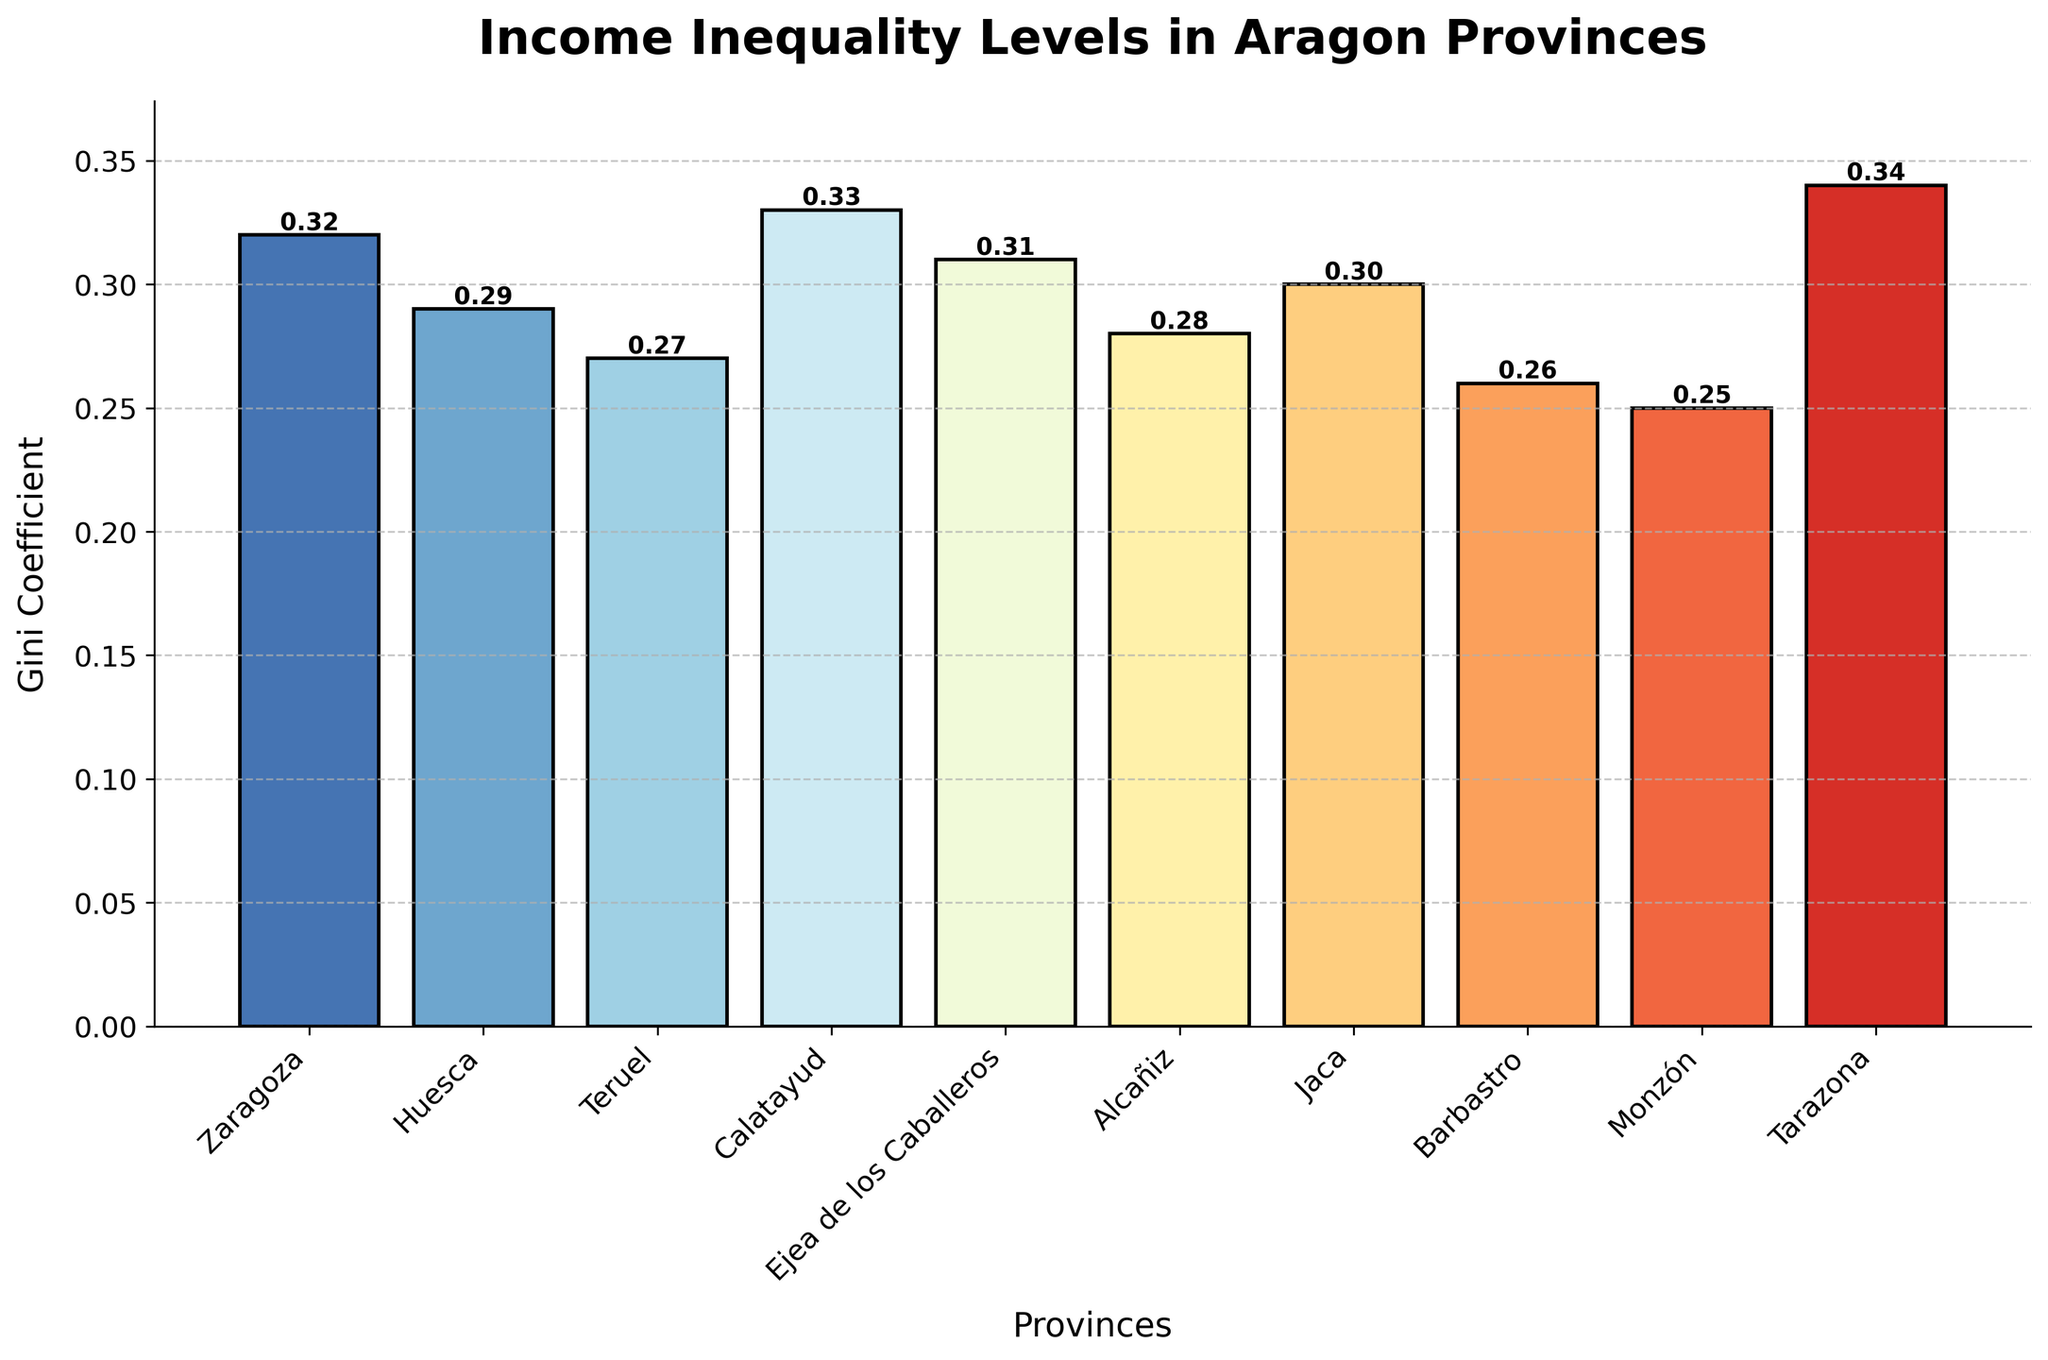Which province has the highest Gini Coefficient? The highest bar represents the highest Gini Coefficient. This is the bar for Tarazona with a Gini Coefficient of 0.34.
Answer: Tarazona Which province has the lowest Gini Coefficient? The lowest bar represents the lowest Gini Coefficient. This is the bar for Monzón with a Gini Coefficient of 0.25.
Answer: Monzón How much higher is the Gini Coefficient in Calatayud compared to Teruel? The Gini Coefficients of Calatayud and Teruel are 0.33 and 0.27, respectively. The difference is 0.33 - 0.27 = 0.06.
Answer: 0.06 What is the average Gini Coefficient of all the provinces? Sum all the Gini Coefficients and divide by the number of provinces: (0.32 + 0.29 + 0.27 + 0.33 + 0.31 + 0.28 + 0.30 + 0.26 + 0.25 + 0.34) / 10 = 2.95 / 10 = 0.295.
Answer: 0.295 What is the range of the Gini Coefficient values? Subtract the smallest Gini Coefficient from the largest: 0.34 - 0.25 = 0.09.
Answer: 0.09 Are there more provinces with a Gini Coefficient above 0.30 or below 0.30? Identify the provinces: above 0.30 are Zaragoza, Calatayud, Ejea de los Caballeros, Jaca, and Tarazona (5 provinces); below 0.30 are Huesca, Teruel, Alcañiz, Barbastro, Monzón (5 provinces). They are equal.
Answer: Equal Which bars are visually the tallest and the shortest? The visually tallest bar represents Tarazona (0.34), and the visually shortest bar represents Monzón (0.25).
Answer: Tarazona and Monzón What is the difference in Gini Coefficient between the province with the highest Gini Coefficient and the province with the lowest Gini Coefficient? The highest Gini Coefficient is for Tarazona (0.34), and the lowest is for Monzón (0.25). The difference is 0.34 - 0.25 = 0.09.
Answer: 0.09 What is the total sum of the Gini Coefficients for all the provinces? Add all the Gini Coefficients together: 0.32+0.29+0.27+0.33+0.31+0.28+0.30+0.26+0.25+0.34 = 2.95.
Answer: 2.95 